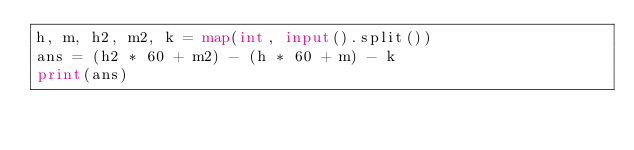Convert code to text. <code><loc_0><loc_0><loc_500><loc_500><_Python_>h, m, h2, m2, k = map(int, input().split())
ans = (h2 * 60 + m2) - (h * 60 + m) - k
print(ans)</code> 